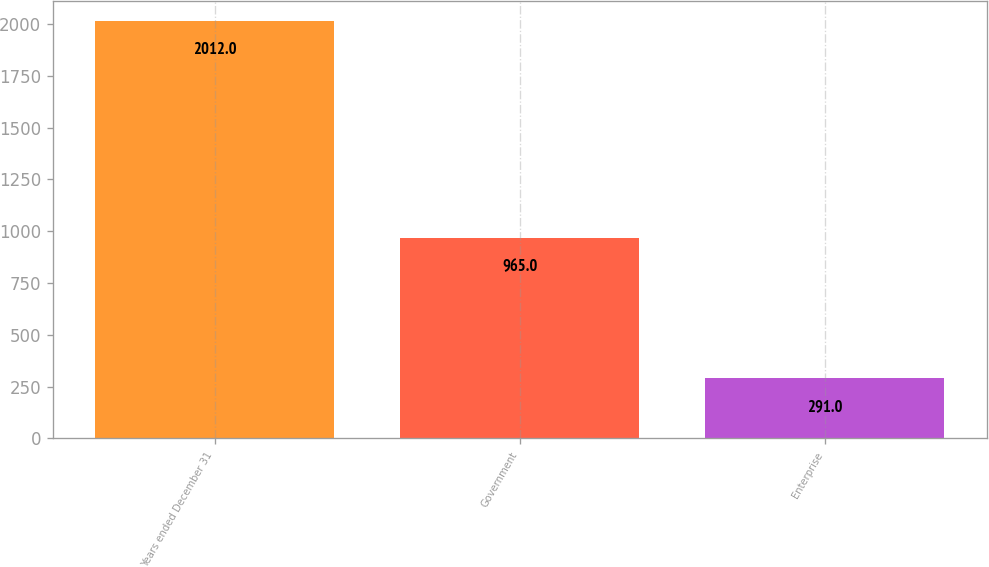Convert chart to OTSL. <chart><loc_0><loc_0><loc_500><loc_500><bar_chart><fcel>Years ended December 31<fcel>Government<fcel>Enterprise<nl><fcel>2012<fcel>965<fcel>291<nl></chart> 